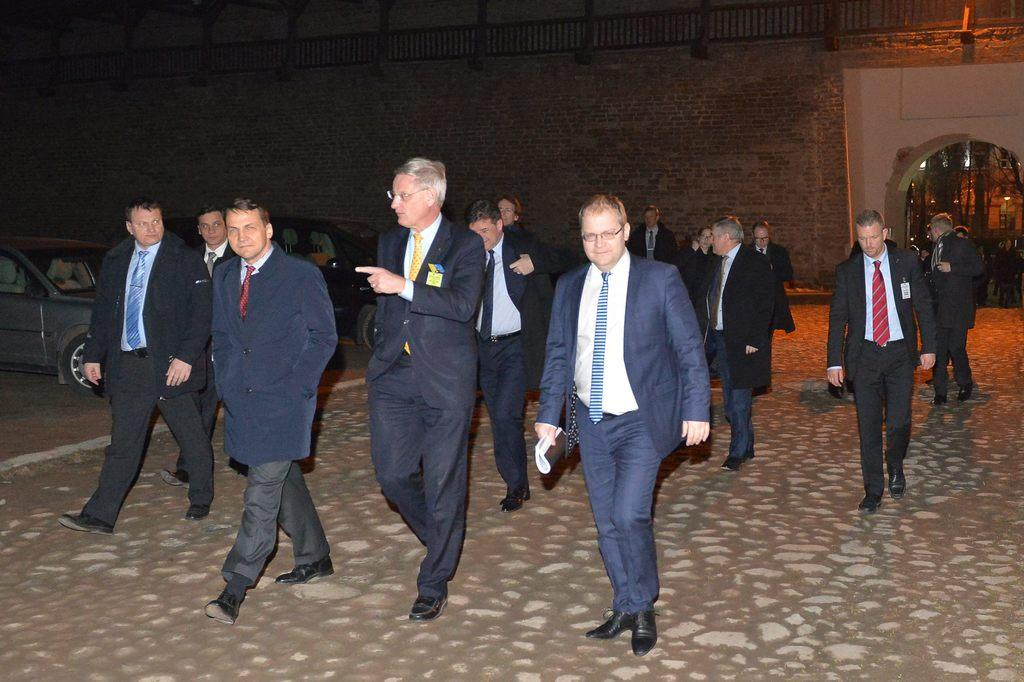What are the persons in the image doing? The persons in the image are walking. On what surface are the persons walking? The persons are walking on the floor. What else can be seen in the image besides the persons walking? Motor vehicles are visible in the image. What type of architectural feature can be seen in the image? There is a wall and an arch in the image. What type of shop can be seen in the image? There is no shop present in the image. How many people are in the crowd in the image? There is no crowd present in the image; only a few persons are walking. 